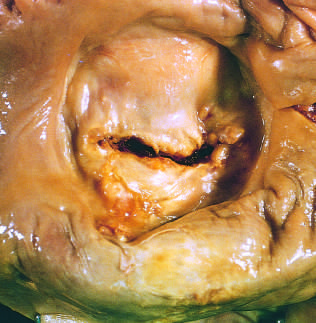s high-power view of another region marked left atrial dilation as seen from above the valve?
Answer the question using a single word or phrase. No 